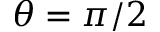<formula> <loc_0><loc_0><loc_500><loc_500>\theta = \pi / 2</formula> 